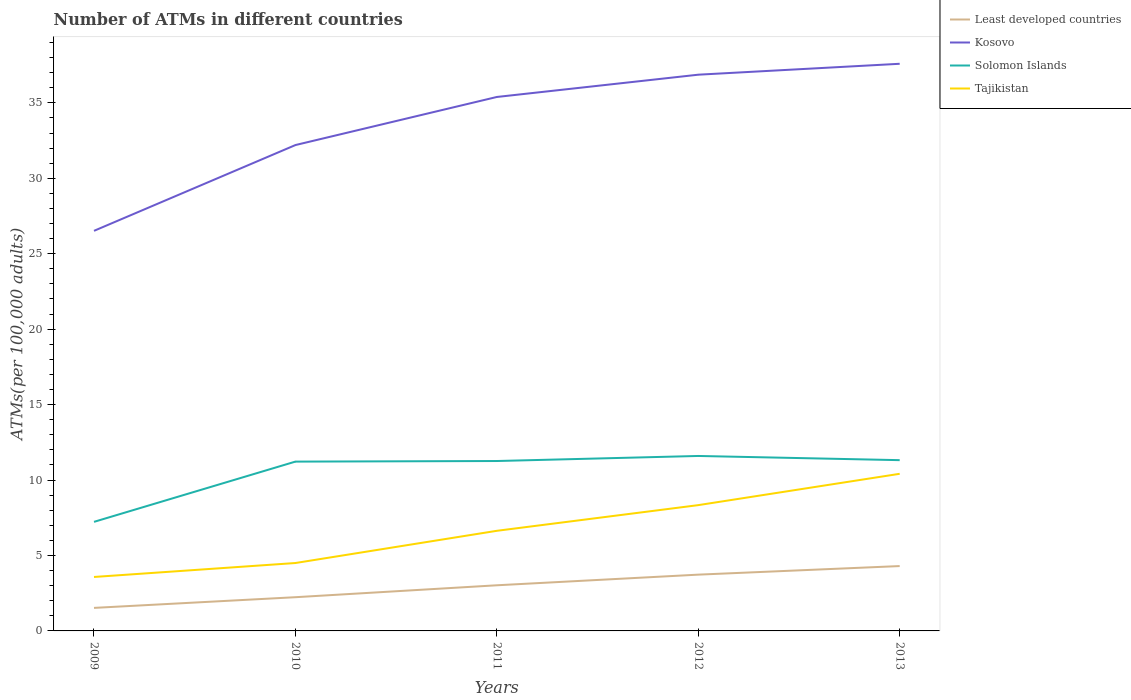Does the line corresponding to Least developed countries intersect with the line corresponding to Solomon Islands?
Your response must be concise. No. Is the number of lines equal to the number of legend labels?
Keep it short and to the point. Yes. Across all years, what is the maximum number of ATMs in Tajikistan?
Provide a succinct answer. 3.58. In which year was the number of ATMs in Solomon Islands maximum?
Give a very brief answer. 2009. What is the total number of ATMs in Tajikistan in the graph?
Your answer should be very brief. -4.76. What is the difference between the highest and the second highest number of ATMs in Solomon Islands?
Make the answer very short. 4.37. What is the difference between the highest and the lowest number of ATMs in Kosovo?
Make the answer very short. 3. Is the number of ATMs in Least developed countries strictly greater than the number of ATMs in Solomon Islands over the years?
Keep it short and to the point. Yes. How many years are there in the graph?
Provide a short and direct response. 5. Are the values on the major ticks of Y-axis written in scientific E-notation?
Your answer should be very brief. No. Does the graph contain grids?
Offer a terse response. No. Where does the legend appear in the graph?
Provide a succinct answer. Top right. How many legend labels are there?
Give a very brief answer. 4. What is the title of the graph?
Keep it short and to the point. Number of ATMs in different countries. Does "Kazakhstan" appear as one of the legend labels in the graph?
Offer a terse response. No. What is the label or title of the X-axis?
Provide a short and direct response. Years. What is the label or title of the Y-axis?
Ensure brevity in your answer.  ATMs(per 100,0 adults). What is the ATMs(per 100,000 adults) of Least developed countries in 2009?
Your answer should be compact. 1.53. What is the ATMs(per 100,000 adults) in Kosovo in 2009?
Provide a succinct answer. 26.52. What is the ATMs(per 100,000 adults) of Solomon Islands in 2009?
Your answer should be compact. 7.23. What is the ATMs(per 100,000 adults) in Tajikistan in 2009?
Keep it short and to the point. 3.58. What is the ATMs(per 100,000 adults) in Least developed countries in 2010?
Offer a terse response. 2.23. What is the ATMs(per 100,000 adults) of Kosovo in 2010?
Offer a terse response. 32.2. What is the ATMs(per 100,000 adults) in Solomon Islands in 2010?
Ensure brevity in your answer.  11.22. What is the ATMs(per 100,000 adults) in Tajikistan in 2010?
Your answer should be compact. 4.5. What is the ATMs(per 100,000 adults) in Least developed countries in 2011?
Offer a terse response. 3.02. What is the ATMs(per 100,000 adults) of Kosovo in 2011?
Your answer should be very brief. 35.39. What is the ATMs(per 100,000 adults) of Solomon Islands in 2011?
Ensure brevity in your answer.  11.26. What is the ATMs(per 100,000 adults) in Tajikistan in 2011?
Your answer should be compact. 6.64. What is the ATMs(per 100,000 adults) in Least developed countries in 2012?
Your answer should be very brief. 3.73. What is the ATMs(per 100,000 adults) of Kosovo in 2012?
Make the answer very short. 36.86. What is the ATMs(per 100,000 adults) in Solomon Islands in 2012?
Offer a terse response. 11.6. What is the ATMs(per 100,000 adults) of Tajikistan in 2012?
Your response must be concise. 8.34. What is the ATMs(per 100,000 adults) in Least developed countries in 2013?
Make the answer very short. 4.3. What is the ATMs(per 100,000 adults) of Kosovo in 2013?
Offer a terse response. 37.59. What is the ATMs(per 100,000 adults) in Solomon Islands in 2013?
Your answer should be compact. 11.32. What is the ATMs(per 100,000 adults) in Tajikistan in 2013?
Make the answer very short. 10.41. Across all years, what is the maximum ATMs(per 100,000 adults) of Least developed countries?
Keep it short and to the point. 4.3. Across all years, what is the maximum ATMs(per 100,000 adults) in Kosovo?
Offer a terse response. 37.59. Across all years, what is the maximum ATMs(per 100,000 adults) of Solomon Islands?
Your response must be concise. 11.6. Across all years, what is the maximum ATMs(per 100,000 adults) in Tajikistan?
Provide a succinct answer. 10.41. Across all years, what is the minimum ATMs(per 100,000 adults) in Least developed countries?
Provide a short and direct response. 1.53. Across all years, what is the minimum ATMs(per 100,000 adults) of Kosovo?
Offer a very short reply. 26.52. Across all years, what is the minimum ATMs(per 100,000 adults) in Solomon Islands?
Give a very brief answer. 7.23. Across all years, what is the minimum ATMs(per 100,000 adults) of Tajikistan?
Your answer should be very brief. 3.58. What is the total ATMs(per 100,000 adults) in Least developed countries in the graph?
Make the answer very short. 14.81. What is the total ATMs(per 100,000 adults) of Kosovo in the graph?
Offer a terse response. 168.56. What is the total ATMs(per 100,000 adults) of Solomon Islands in the graph?
Make the answer very short. 52.62. What is the total ATMs(per 100,000 adults) in Tajikistan in the graph?
Your answer should be compact. 33.46. What is the difference between the ATMs(per 100,000 adults) in Least developed countries in 2009 and that in 2010?
Your response must be concise. -0.71. What is the difference between the ATMs(per 100,000 adults) in Kosovo in 2009 and that in 2010?
Offer a very short reply. -5.68. What is the difference between the ATMs(per 100,000 adults) of Solomon Islands in 2009 and that in 2010?
Provide a short and direct response. -3.99. What is the difference between the ATMs(per 100,000 adults) of Tajikistan in 2009 and that in 2010?
Offer a very short reply. -0.93. What is the difference between the ATMs(per 100,000 adults) of Least developed countries in 2009 and that in 2011?
Offer a very short reply. -1.5. What is the difference between the ATMs(per 100,000 adults) in Kosovo in 2009 and that in 2011?
Keep it short and to the point. -8.87. What is the difference between the ATMs(per 100,000 adults) of Solomon Islands in 2009 and that in 2011?
Keep it short and to the point. -4.03. What is the difference between the ATMs(per 100,000 adults) in Tajikistan in 2009 and that in 2011?
Offer a very short reply. -3.06. What is the difference between the ATMs(per 100,000 adults) in Least developed countries in 2009 and that in 2012?
Keep it short and to the point. -2.2. What is the difference between the ATMs(per 100,000 adults) of Kosovo in 2009 and that in 2012?
Offer a very short reply. -10.35. What is the difference between the ATMs(per 100,000 adults) of Solomon Islands in 2009 and that in 2012?
Your answer should be very brief. -4.37. What is the difference between the ATMs(per 100,000 adults) of Tajikistan in 2009 and that in 2012?
Make the answer very short. -4.76. What is the difference between the ATMs(per 100,000 adults) in Least developed countries in 2009 and that in 2013?
Provide a short and direct response. -2.77. What is the difference between the ATMs(per 100,000 adults) of Kosovo in 2009 and that in 2013?
Provide a short and direct response. -11.07. What is the difference between the ATMs(per 100,000 adults) in Solomon Islands in 2009 and that in 2013?
Provide a short and direct response. -4.09. What is the difference between the ATMs(per 100,000 adults) of Tajikistan in 2009 and that in 2013?
Offer a very short reply. -6.84. What is the difference between the ATMs(per 100,000 adults) of Least developed countries in 2010 and that in 2011?
Ensure brevity in your answer.  -0.79. What is the difference between the ATMs(per 100,000 adults) of Kosovo in 2010 and that in 2011?
Ensure brevity in your answer.  -3.19. What is the difference between the ATMs(per 100,000 adults) of Solomon Islands in 2010 and that in 2011?
Your answer should be compact. -0.04. What is the difference between the ATMs(per 100,000 adults) in Tajikistan in 2010 and that in 2011?
Provide a succinct answer. -2.13. What is the difference between the ATMs(per 100,000 adults) in Least developed countries in 2010 and that in 2012?
Offer a very short reply. -1.5. What is the difference between the ATMs(per 100,000 adults) of Kosovo in 2010 and that in 2012?
Offer a very short reply. -4.66. What is the difference between the ATMs(per 100,000 adults) in Solomon Islands in 2010 and that in 2012?
Make the answer very short. -0.37. What is the difference between the ATMs(per 100,000 adults) of Tajikistan in 2010 and that in 2012?
Give a very brief answer. -3.84. What is the difference between the ATMs(per 100,000 adults) in Least developed countries in 2010 and that in 2013?
Provide a succinct answer. -2.06. What is the difference between the ATMs(per 100,000 adults) of Kosovo in 2010 and that in 2013?
Keep it short and to the point. -5.39. What is the difference between the ATMs(per 100,000 adults) of Solomon Islands in 2010 and that in 2013?
Give a very brief answer. -0.1. What is the difference between the ATMs(per 100,000 adults) of Tajikistan in 2010 and that in 2013?
Your response must be concise. -5.91. What is the difference between the ATMs(per 100,000 adults) in Least developed countries in 2011 and that in 2012?
Give a very brief answer. -0.7. What is the difference between the ATMs(per 100,000 adults) of Kosovo in 2011 and that in 2012?
Provide a short and direct response. -1.48. What is the difference between the ATMs(per 100,000 adults) of Solomon Islands in 2011 and that in 2012?
Ensure brevity in your answer.  -0.33. What is the difference between the ATMs(per 100,000 adults) of Tajikistan in 2011 and that in 2012?
Ensure brevity in your answer.  -1.7. What is the difference between the ATMs(per 100,000 adults) of Least developed countries in 2011 and that in 2013?
Your response must be concise. -1.27. What is the difference between the ATMs(per 100,000 adults) of Kosovo in 2011 and that in 2013?
Make the answer very short. -2.2. What is the difference between the ATMs(per 100,000 adults) in Solomon Islands in 2011 and that in 2013?
Offer a very short reply. -0.06. What is the difference between the ATMs(per 100,000 adults) in Tajikistan in 2011 and that in 2013?
Give a very brief answer. -3.78. What is the difference between the ATMs(per 100,000 adults) of Least developed countries in 2012 and that in 2013?
Provide a succinct answer. -0.57. What is the difference between the ATMs(per 100,000 adults) in Kosovo in 2012 and that in 2013?
Provide a succinct answer. -0.72. What is the difference between the ATMs(per 100,000 adults) in Solomon Islands in 2012 and that in 2013?
Your response must be concise. 0.28. What is the difference between the ATMs(per 100,000 adults) in Tajikistan in 2012 and that in 2013?
Your answer should be very brief. -2.08. What is the difference between the ATMs(per 100,000 adults) in Least developed countries in 2009 and the ATMs(per 100,000 adults) in Kosovo in 2010?
Offer a terse response. -30.68. What is the difference between the ATMs(per 100,000 adults) in Least developed countries in 2009 and the ATMs(per 100,000 adults) in Solomon Islands in 2010?
Offer a very short reply. -9.7. What is the difference between the ATMs(per 100,000 adults) in Least developed countries in 2009 and the ATMs(per 100,000 adults) in Tajikistan in 2010?
Your answer should be compact. -2.97. What is the difference between the ATMs(per 100,000 adults) of Kosovo in 2009 and the ATMs(per 100,000 adults) of Solomon Islands in 2010?
Offer a very short reply. 15.29. What is the difference between the ATMs(per 100,000 adults) in Kosovo in 2009 and the ATMs(per 100,000 adults) in Tajikistan in 2010?
Your answer should be compact. 22.02. What is the difference between the ATMs(per 100,000 adults) of Solomon Islands in 2009 and the ATMs(per 100,000 adults) of Tajikistan in 2010?
Offer a very short reply. 2.73. What is the difference between the ATMs(per 100,000 adults) in Least developed countries in 2009 and the ATMs(per 100,000 adults) in Kosovo in 2011?
Make the answer very short. -33.86. What is the difference between the ATMs(per 100,000 adults) in Least developed countries in 2009 and the ATMs(per 100,000 adults) in Solomon Islands in 2011?
Ensure brevity in your answer.  -9.73. What is the difference between the ATMs(per 100,000 adults) in Least developed countries in 2009 and the ATMs(per 100,000 adults) in Tajikistan in 2011?
Keep it short and to the point. -5.11. What is the difference between the ATMs(per 100,000 adults) of Kosovo in 2009 and the ATMs(per 100,000 adults) of Solomon Islands in 2011?
Offer a very short reply. 15.26. What is the difference between the ATMs(per 100,000 adults) in Kosovo in 2009 and the ATMs(per 100,000 adults) in Tajikistan in 2011?
Provide a short and direct response. 19.88. What is the difference between the ATMs(per 100,000 adults) of Solomon Islands in 2009 and the ATMs(per 100,000 adults) of Tajikistan in 2011?
Give a very brief answer. 0.59. What is the difference between the ATMs(per 100,000 adults) of Least developed countries in 2009 and the ATMs(per 100,000 adults) of Kosovo in 2012?
Offer a terse response. -35.34. What is the difference between the ATMs(per 100,000 adults) of Least developed countries in 2009 and the ATMs(per 100,000 adults) of Solomon Islands in 2012?
Give a very brief answer. -10.07. What is the difference between the ATMs(per 100,000 adults) in Least developed countries in 2009 and the ATMs(per 100,000 adults) in Tajikistan in 2012?
Ensure brevity in your answer.  -6.81. What is the difference between the ATMs(per 100,000 adults) of Kosovo in 2009 and the ATMs(per 100,000 adults) of Solomon Islands in 2012?
Your answer should be very brief. 14.92. What is the difference between the ATMs(per 100,000 adults) in Kosovo in 2009 and the ATMs(per 100,000 adults) in Tajikistan in 2012?
Keep it short and to the point. 18.18. What is the difference between the ATMs(per 100,000 adults) of Solomon Islands in 2009 and the ATMs(per 100,000 adults) of Tajikistan in 2012?
Ensure brevity in your answer.  -1.11. What is the difference between the ATMs(per 100,000 adults) in Least developed countries in 2009 and the ATMs(per 100,000 adults) in Kosovo in 2013?
Your response must be concise. -36.06. What is the difference between the ATMs(per 100,000 adults) in Least developed countries in 2009 and the ATMs(per 100,000 adults) in Solomon Islands in 2013?
Provide a succinct answer. -9.79. What is the difference between the ATMs(per 100,000 adults) of Least developed countries in 2009 and the ATMs(per 100,000 adults) of Tajikistan in 2013?
Provide a short and direct response. -8.89. What is the difference between the ATMs(per 100,000 adults) of Kosovo in 2009 and the ATMs(per 100,000 adults) of Solomon Islands in 2013?
Your answer should be very brief. 15.2. What is the difference between the ATMs(per 100,000 adults) of Kosovo in 2009 and the ATMs(per 100,000 adults) of Tajikistan in 2013?
Provide a short and direct response. 16.1. What is the difference between the ATMs(per 100,000 adults) in Solomon Islands in 2009 and the ATMs(per 100,000 adults) in Tajikistan in 2013?
Offer a very short reply. -3.18. What is the difference between the ATMs(per 100,000 adults) of Least developed countries in 2010 and the ATMs(per 100,000 adults) of Kosovo in 2011?
Your answer should be compact. -33.15. What is the difference between the ATMs(per 100,000 adults) in Least developed countries in 2010 and the ATMs(per 100,000 adults) in Solomon Islands in 2011?
Make the answer very short. -9.03. What is the difference between the ATMs(per 100,000 adults) in Least developed countries in 2010 and the ATMs(per 100,000 adults) in Tajikistan in 2011?
Offer a terse response. -4.4. What is the difference between the ATMs(per 100,000 adults) in Kosovo in 2010 and the ATMs(per 100,000 adults) in Solomon Islands in 2011?
Provide a succinct answer. 20.94. What is the difference between the ATMs(per 100,000 adults) of Kosovo in 2010 and the ATMs(per 100,000 adults) of Tajikistan in 2011?
Ensure brevity in your answer.  25.57. What is the difference between the ATMs(per 100,000 adults) of Solomon Islands in 2010 and the ATMs(per 100,000 adults) of Tajikistan in 2011?
Give a very brief answer. 4.59. What is the difference between the ATMs(per 100,000 adults) of Least developed countries in 2010 and the ATMs(per 100,000 adults) of Kosovo in 2012?
Ensure brevity in your answer.  -34.63. What is the difference between the ATMs(per 100,000 adults) of Least developed countries in 2010 and the ATMs(per 100,000 adults) of Solomon Islands in 2012?
Make the answer very short. -9.36. What is the difference between the ATMs(per 100,000 adults) of Least developed countries in 2010 and the ATMs(per 100,000 adults) of Tajikistan in 2012?
Give a very brief answer. -6.1. What is the difference between the ATMs(per 100,000 adults) of Kosovo in 2010 and the ATMs(per 100,000 adults) of Solomon Islands in 2012?
Make the answer very short. 20.61. What is the difference between the ATMs(per 100,000 adults) in Kosovo in 2010 and the ATMs(per 100,000 adults) in Tajikistan in 2012?
Your answer should be very brief. 23.86. What is the difference between the ATMs(per 100,000 adults) of Solomon Islands in 2010 and the ATMs(per 100,000 adults) of Tajikistan in 2012?
Provide a short and direct response. 2.88. What is the difference between the ATMs(per 100,000 adults) in Least developed countries in 2010 and the ATMs(per 100,000 adults) in Kosovo in 2013?
Keep it short and to the point. -35.35. What is the difference between the ATMs(per 100,000 adults) in Least developed countries in 2010 and the ATMs(per 100,000 adults) in Solomon Islands in 2013?
Your answer should be very brief. -9.08. What is the difference between the ATMs(per 100,000 adults) in Least developed countries in 2010 and the ATMs(per 100,000 adults) in Tajikistan in 2013?
Provide a short and direct response. -8.18. What is the difference between the ATMs(per 100,000 adults) in Kosovo in 2010 and the ATMs(per 100,000 adults) in Solomon Islands in 2013?
Provide a succinct answer. 20.88. What is the difference between the ATMs(per 100,000 adults) of Kosovo in 2010 and the ATMs(per 100,000 adults) of Tajikistan in 2013?
Provide a succinct answer. 21.79. What is the difference between the ATMs(per 100,000 adults) in Solomon Islands in 2010 and the ATMs(per 100,000 adults) in Tajikistan in 2013?
Your answer should be very brief. 0.81. What is the difference between the ATMs(per 100,000 adults) of Least developed countries in 2011 and the ATMs(per 100,000 adults) of Kosovo in 2012?
Your response must be concise. -33.84. What is the difference between the ATMs(per 100,000 adults) of Least developed countries in 2011 and the ATMs(per 100,000 adults) of Solomon Islands in 2012?
Offer a terse response. -8.57. What is the difference between the ATMs(per 100,000 adults) in Least developed countries in 2011 and the ATMs(per 100,000 adults) in Tajikistan in 2012?
Provide a succinct answer. -5.31. What is the difference between the ATMs(per 100,000 adults) of Kosovo in 2011 and the ATMs(per 100,000 adults) of Solomon Islands in 2012?
Offer a very short reply. 23.79. What is the difference between the ATMs(per 100,000 adults) of Kosovo in 2011 and the ATMs(per 100,000 adults) of Tajikistan in 2012?
Provide a succinct answer. 27.05. What is the difference between the ATMs(per 100,000 adults) in Solomon Islands in 2011 and the ATMs(per 100,000 adults) in Tajikistan in 2012?
Offer a terse response. 2.92. What is the difference between the ATMs(per 100,000 adults) of Least developed countries in 2011 and the ATMs(per 100,000 adults) of Kosovo in 2013?
Provide a succinct answer. -34.56. What is the difference between the ATMs(per 100,000 adults) of Least developed countries in 2011 and the ATMs(per 100,000 adults) of Solomon Islands in 2013?
Your answer should be compact. -8.29. What is the difference between the ATMs(per 100,000 adults) of Least developed countries in 2011 and the ATMs(per 100,000 adults) of Tajikistan in 2013?
Keep it short and to the point. -7.39. What is the difference between the ATMs(per 100,000 adults) in Kosovo in 2011 and the ATMs(per 100,000 adults) in Solomon Islands in 2013?
Ensure brevity in your answer.  24.07. What is the difference between the ATMs(per 100,000 adults) of Kosovo in 2011 and the ATMs(per 100,000 adults) of Tajikistan in 2013?
Your response must be concise. 24.97. What is the difference between the ATMs(per 100,000 adults) in Solomon Islands in 2011 and the ATMs(per 100,000 adults) in Tajikistan in 2013?
Your answer should be compact. 0.85. What is the difference between the ATMs(per 100,000 adults) of Least developed countries in 2012 and the ATMs(per 100,000 adults) of Kosovo in 2013?
Provide a succinct answer. -33.86. What is the difference between the ATMs(per 100,000 adults) in Least developed countries in 2012 and the ATMs(per 100,000 adults) in Solomon Islands in 2013?
Ensure brevity in your answer.  -7.59. What is the difference between the ATMs(per 100,000 adults) in Least developed countries in 2012 and the ATMs(per 100,000 adults) in Tajikistan in 2013?
Provide a short and direct response. -6.68. What is the difference between the ATMs(per 100,000 adults) of Kosovo in 2012 and the ATMs(per 100,000 adults) of Solomon Islands in 2013?
Keep it short and to the point. 25.55. What is the difference between the ATMs(per 100,000 adults) of Kosovo in 2012 and the ATMs(per 100,000 adults) of Tajikistan in 2013?
Offer a terse response. 26.45. What is the difference between the ATMs(per 100,000 adults) in Solomon Islands in 2012 and the ATMs(per 100,000 adults) in Tajikistan in 2013?
Provide a succinct answer. 1.18. What is the average ATMs(per 100,000 adults) of Least developed countries per year?
Offer a very short reply. 2.96. What is the average ATMs(per 100,000 adults) in Kosovo per year?
Offer a very short reply. 33.71. What is the average ATMs(per 100,000 adults) of Solomon Islands per year?
Your answer should be very brief. 10.52. What is the average ATMs(per 100,000 adults) of Tajikistan per year?
Your response must be concise. 6.69. In the year 2009, what is the difference between the ATMs(per 100,000 adults) in Least developed countries and ATMs(per 100,000 adults) in Kosovo?
Ensure brevity in your answer.  -24.99. In the year 2009, what is the difference between the ATMs(per 100,000 adults) of Least developed countries and ATMs(per 100,000 adults) of Solomon Islands?
Provide a succinct answer. -5.7. In the year 2009, what is the difference between the ATMs(per 100,000 adults) of Least developed countries and ATMs(per 100,000 adults) of Tajikistan?
Offer a terse response. -2.05. In the year 2009, what is the difference between the ATMs(per 100,000 adults) in Kosovo and ATMs(per 100,000 adults) in Solomon Islands?
Offer a very short reply. 19.29. In the year 2009, what is the difference between the ATMs(per 100,000 adults) of Kosovo and ATMs(per 100,000 adults) of Tajikistan?
Your answer should be very brief. 22.94. In the year 2009, what is the difference between the ATMs(per 100,000 adults) in Solomon Islands and ATMs(per 100,000 adults) in Tajikistan?
Ensure brevity in your answer.  3.65. In the year 2010, what is the difference between the ATMs(per 100,000 adults) in Least developed countries and ATMs(per 100,000 adults) in Kosovo?
Make the answer very short. -29.97. In the year 2010, what is the difference between the ATMs(per 100,000 adults) in Least developed countries and ATMs(per 100,000 adults) in Solomon Islands?
Your response must be concise. -8.99. In the year 2010, what is the difference between the ATMs(per 100,000 adults) in Least developed countries and ATMs(per 100,000 adults) in Tajikistan?
Make the answer very short. -2.27. In the year 2010, what is the difference between the ATMs(per 100,000 adults) of Kosovo and ATMs(per 100,000 adults) of Solomon Islands?
Your answer should be very brief. 20.98. In the year 2010, what is the difference between the ATMs(per 100,000 adults) of Kosovo and ATMs(per 100,000 adults) of Tajikistan?
Keep it short and to the point. 27.7. In the year 2010, what is the difference between the ATMs(per 100,000 adults) in Solomon Islands and ATMs(per 100,000 adults) in Tajikistan?
Your answer should be compact. 6.72. In the year 2011, what is the difference between the ATMs(per 100,000 adults) in Least developed countries and ATMs(per 100,000 adults) in Kosovo?
Keep it short and to the point. -32.36. In the year 2011, what is the difference between the ATMs(per 100,000 adults) in Least developed countries and ATMs(per 100,000 adults) in Solomon Islands?
Keep it short and to the point. -8.24. In the year 2011, what is the difference between the ATMs(per 100,000 adults) of Least developed countries and ATMs(per 100,000 adults) of Tajikistan?
Offer a very short reply. -3.61. In the year 2011, what is the difference between the ATMs(per 100,000 adults) of Kosovo and ATMs(per 100,000 adults) of Solomon Islands?
Your answer should be compact. 24.13. In the year 2011, what is the difference between the ATMs(per 100,000 adults) in Kosovo and ATMs(per 100,000 adults) in Tajikistan?
Your answer should be very brief. 28.75. In the year 2011, what is the difference between the ATMs(per 100,000 adults) of Solomon Islands and ATMs(per 100,000 adults) of Tajikistan?
Your response must be concise. 4.63. In the year 2012, what is the difference between the ATMs(per 100,000 adults) of Least developed countries and ATMs(per 100,000 adults) of Kosovo?
Your answer should be compact. -33.13. In the year 2012, what is the difference between the ATMs(per 100,000 adults) of Least developed countries and ATMs(per 100,000 adults) of Solomon Islands?
Your answer should be compact. -7.87. In the year 2012, what is the difference between the ATMs(per 100,000 adults) of Least developed countries and ATMs(per 100,000 adults) of Tajikistan?
Offer a very short reply. -4.61. In the year 2012, what is the difference between the ATMs(per 100,000 adults) in Kosovo and ATMs(per 100,000 adults) in Solomon Islands?
Ensure brevity in your answer.  25.27. In the year 2012, what is the difference between the ATMs(per 100,000 adults) of Kosovo and ATMs(per 100,000 adults) of Tajikistan?
Make the answer very short. 28.53. In the year 2012, what is the difference between the ATMs(per 100,000 adults) of Solomon Islands and ATMs(per 100,000 adults) of Tajikistan?
Your answer should be very brief. 3.26. In the year 2013, what is the difference between the ATMs(per 100,000 adults) of Least developed countries and ATMs(per 100,000 adults) of Kosovo?
Your answer should be compact. -33.29. In the year 2013, what is the difference between the ATMs(per 100,000 adults) of Least developed countries and ATMs(per 100,000 adults) of Solomon Islands?
Your answer should be compact. -7.02. In the year 2013, what is the difference between the ATMs(per 100,000 adults) in Least developed countries and ATMs(per 100,000 adults) in Tajikistan?
Provide a short and direct response. -6.12. In the year 2013, what is the difference between the ATMs(per 100,000 adults) in Kosovo and ATMs(per 100,000 adults) in Solomon Islands?
Provide a short and direct response. 26.27. In the year 2013, what is the difference between the ATMs(per 100,000 adults) of Kosovo and ATMs(per 100,000 adults) of Tajikistan?
Provide a succinct answer. 27.17. In the year 2013, what is the difference between the ATMs(per 100,000 adults) of Solomon Islands and ATMs(per 100,000 adults) of Tajikistan?
Provide a succinct answer. 0.9. What is the ratio of the ATMs(per 100,000 adults) of Least developed countries in 2009 to that in 2010?
Provide a succinct answer. 0.68. What is the ratio of the ATMs(per 100,000 adults) in Kosovo in 2009 to that in 2010?
Provide a short and direct response. 0.82. What is the ratio of the ATMs(per 100,000 adults) of Solomon Islands in 2009 to that in 2010?
Give a very brief answer. 0.64. What is the ratio of the ATMs(per 100,000 adults) of Tajikistan in 2009 to that in 2010?
Keep it short and to the point. 0.79. What is the ratio of the ATMs(per 100,000 adults) in Least developed countries in 2009 to that in 2011?
Offer a very short reply. 0.5. What is the ratio of the ATMs(per 100,000 adults) of Kosovo in 2009 to that in 2011?
Give a very brief answer. 0.75. What is the ratio of the ATMs(per 100,000 adults) of Solomon Islands in 2009 to that in 2011?
Provide a succinct answer. 0.64. What is the ratio of the ATMs(per 100,000 adults) in Tajikistan in 2009 to that in 2011?
Give a very brief answer. 0.54. What is the ratio of the ATMs(per 100,000 adults) of Least developed countries in 2009 to that in 2012?
Offer a terse response. 0.41. What is the ratio of the ATMs(per 100,000 adults) in Kosovo in 2009 to that in 2012?
Offer a terse response. 0.72. What is the ratio of the ATMs(per 100,000 adults) of Solomon Islands in 2009 to that in 2012?
Provide a succinct answer. 0.62. What is the ratio of the ATMs(per 100,000 adults) of Tajikistan in 2009 to that in 2012?
Provide a succinct answer. 0.43. What is the ratio of the ATMs(per 100,000 adults) in Least developed countries in 2009 to that in 2013?
Your answer should be very brief. 0.36. What is the ratio of the ATMs(per 100,000 adults) in Kosovo in 2009 to that in 2013?
Offer a very short reply. 0.71. What is the ratio of the ATMs(per 100,000 adults) of Solomon Islands in 2009 to that in 2013?
Offer a very short reply. 0.64. What is the ratio of the ATMs(per 100,000 adults) in Tajikistan in 2009 to that in 2013?
Provide a short and direct response. 0.34. What is the ratio of the ATMs(per 100,000 adults) of Least developed countries in 2010 to that in 2011?
Keep it short and to the point. 0.74. What is the ratio of the ATMs(per 100,000 adults) of Kosovo in 2010 to that in 2011?
Offer a terse response. 0.91. What is the ratio of the ATMs(per 100,000 adults) in Tajikistan in 2010 to that in 2011?
Give a very brief answer. 0.68. What is the ratio of the ATMs(per 100,000 adults) in Least developed countries in 2010 to that in 2012?
Keep it short and to the point. 0.6. What is the ratio of the ATMs(per 100,000 adults) in Kosovo in 2010 to that in 2012?
Provide a short and direct response. 0.87. What is the ratio of the ATMs(per 100,000 adults) in Tajikistan in 2010 to that in 2012?
Offer a terse response. 0.54. What is the ratio of the ATMs(per 100,000 adults) of Least developed countries in 2010 to that in 2013?
Your answer should be compact. 0.52. What is the ratio of the ATMs(per 100,000 adults) of Kosovo in 2010 to that in 2013?
Provide a short and direct response. 0.86. What is the ratio of the ATMs(per 100,000 adults) in Solomon Islands in 2010 to that in 2013?
Make the answer very short. 0.99. What is the ratio of the ATMs(per 100,000 adults) in Tajikistan in 2010 to that in 2013?
Offer a very short reply. 0.43. What is the ratio of the ATMs(per 100,000 adults) of Least developed countries in 2011 to that in 2012?
Give a very brief answer. 0.81. What is the ratio of the ATMs(per 100,000 adults) of Solomon Islands in 2011 to that in 2012?
Provide a short and direct response. 0.97. What is the ratio of the ATMs(per 100,000 adults) in Tajikistan in 2011 to that in 2012?
Make the answer very short. 0.8. What is the ratio of the ATMs(per 100,000 adults) in Least developed countries in 2011 to that in 2013?
Provide a short and direct response. 0.7. What is the ratio of the ATMs(per 100,000 adults) in Kosovo in 2011 to that in 2013?
Your answer should be compact. 0.94. What is the ratio of the ATMs(per 100,000 adults) of Tajikistan in 2011 to that in 2013?
Your answer should be compact. 0.64. What is the ratio of the ATMs(per 100,000 adults) of Least developed countries in 2012 to that in 2013?
Provide a short and direct response. 0.87. What is the ratio of the ATMs(per 100,000 adults) in Kosovo in 2012 to that in 2013?
Provide a short and direct response. 0.98. What is the ratio of the ATMs(per 100,000 adults) of Solomon Islands in 2012 to that in 2013?
Your answer should be compact. 1.02. What is the ratio of the ATMs(per 100,000 adults) in Tajikistan in 2012 to that in 2013?
Offer a terse response. 0.8. What is the difference between the highest and the second highest ATMs(per 100,000 adults) of Least developed countries?
Your answer should be compact. 0.57. What is the difference between the highest and the second highest ATMs(per 100,000 adults) in Kosovo?
Offer a terse response. 0.72. What is the difference between the highest and the second highest ATMs(per 100,000 adults) in Solomon Islands?
Your answer should be compact. 0.28. What is the difference between the highest and the second highest ATMs(per 100,000 adults) in Tajikistan?
Provide a succinct answer. 2.08. What is the difference between the highest and the lowest ATMs(per 100,000 adults) of Least developed countries?
Provide a short and direct response. 2.77. What is the difference between the highest and the lowest ATMs(per 100,000 adults) in Kosovo?
Make the answer very short. 11.07. What is the difference between the highest and the lowest ATMs(per 100,000 adults) of Solomon Islands?
Your answer should be very brief. 4.37. What is the difference between the highest and the lowest ATMs(per 100,000 adults) of Tajikistan?
Make the answer very short. 6.84. 